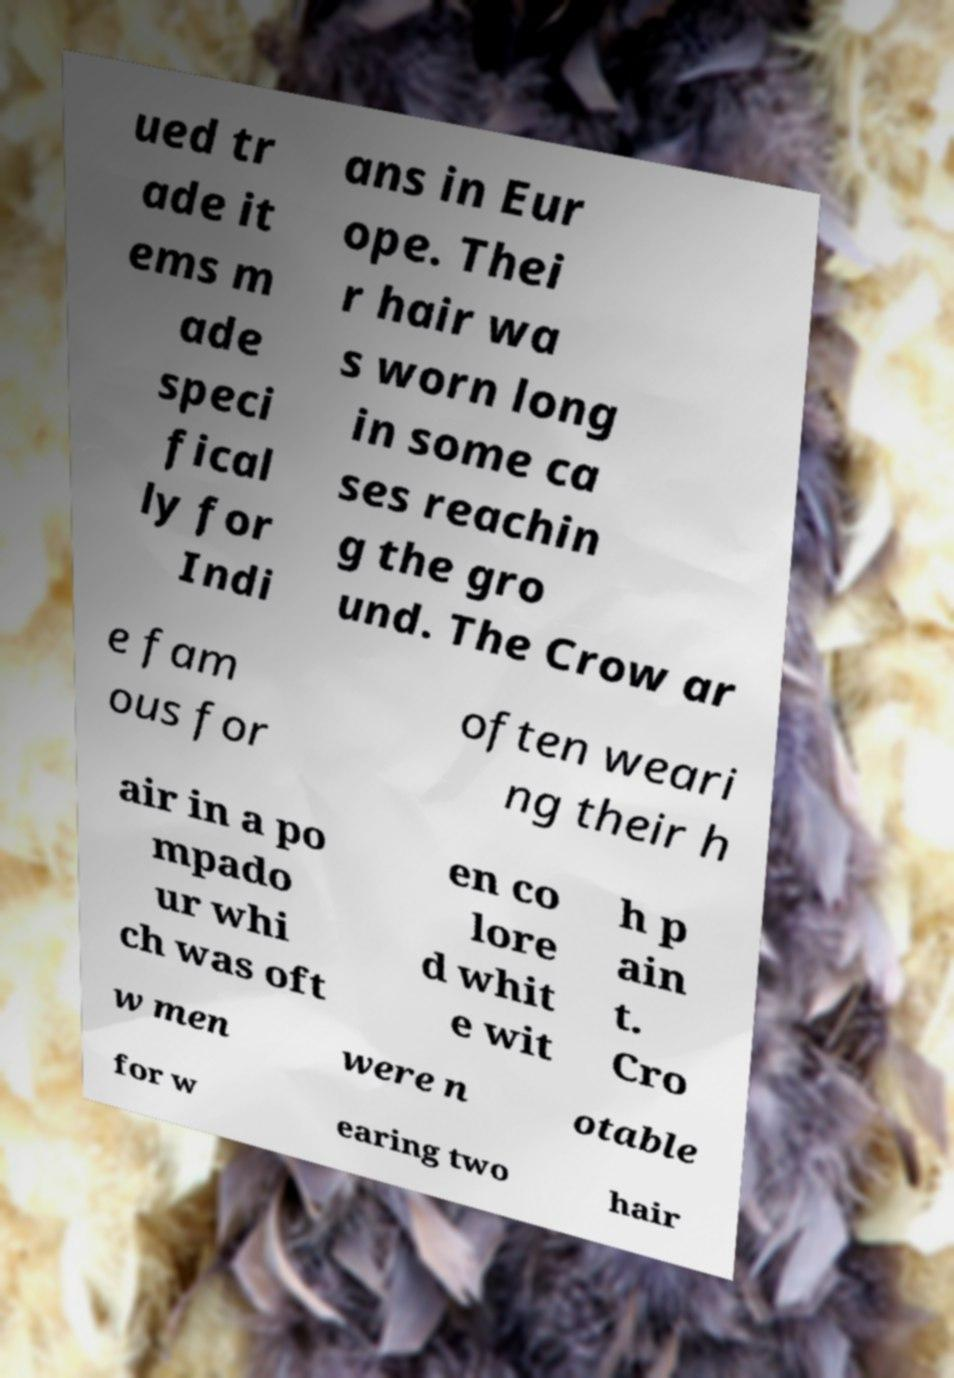Could you extract and type out the text from this image? ued tr ade it ems m ade speci fical ly for Indi ans in Eur ope. Thei r hair wa s worn long in some ca ses reachin g the gro und. The Crow ar e fam ous for often weari ng their h air in a po mpado ur whi ch was oft en co lore d whit e wit h p ain t. Cro w men were n otable for w earing two hair 